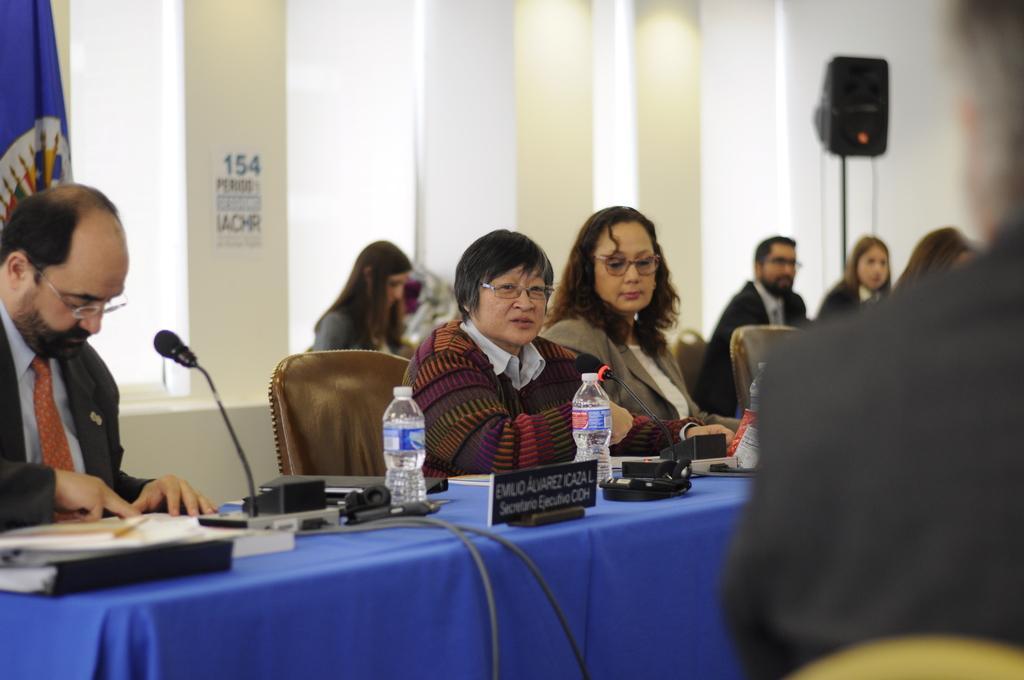Please provide a concise description of this image. There are many persons sitting on chairs. There is a table. On the table there are books, mic, bottles, name plates and many other item. The person sitting in the end is wearing specs. There is a flag behind him. 